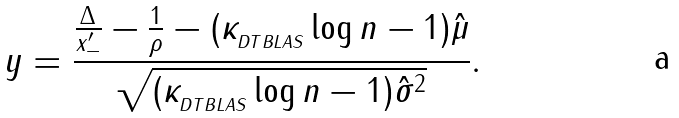<formula> <loc_0><loc_0><loc_500><loc_500>y = \frac { \frac { \Delta } { x _ { - } ^ { \prime } } - \frac { 1 } { \rho } - ( \kappa _ { _ { D T B L A S } } \log n - 1 ) \hat { \mu } } { \sqrt { ( \kappa _ { _ { D T B L A S } } \log n - 1 ) \hat { \sigma } ^ { 2 } } } .</formula> 